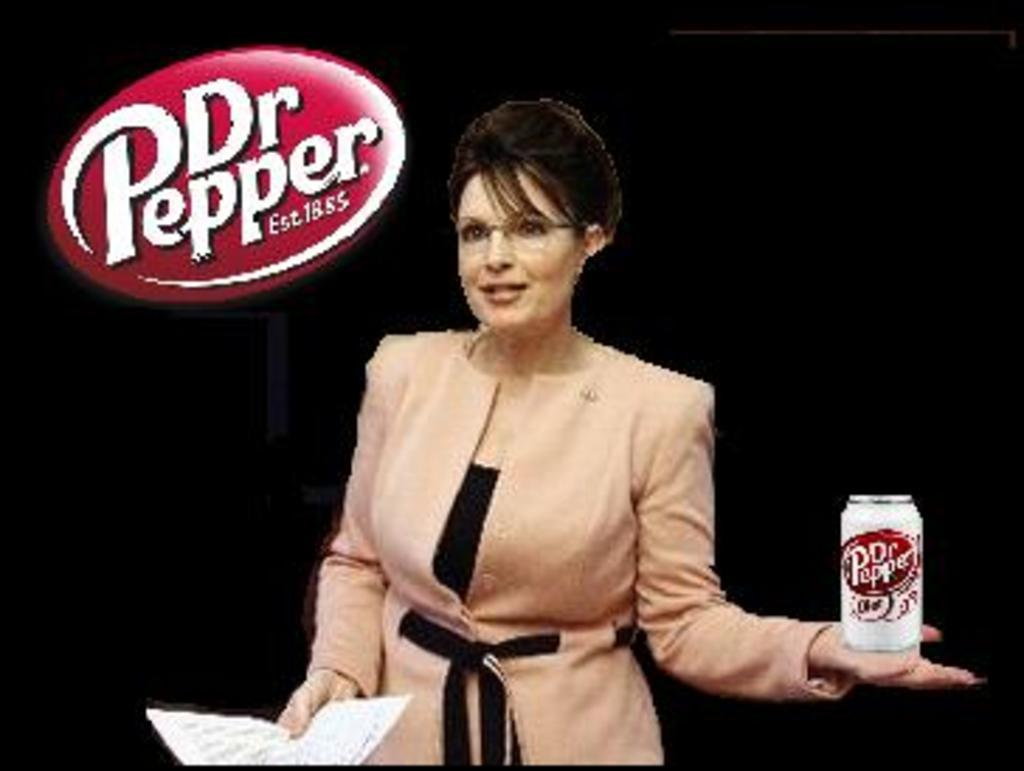Who is present in the image? There is a woman in the image. What is the woman holding in her hands? The woman is holding a paper and a can. What can be observed about the background of the image? The background of the image is dark. Is there any branding or identification in the image? Yes, there is a logo on the image. What type of creature can be seen struggling in the quicksand in the image? There is no quicksand or creature present in the image. 